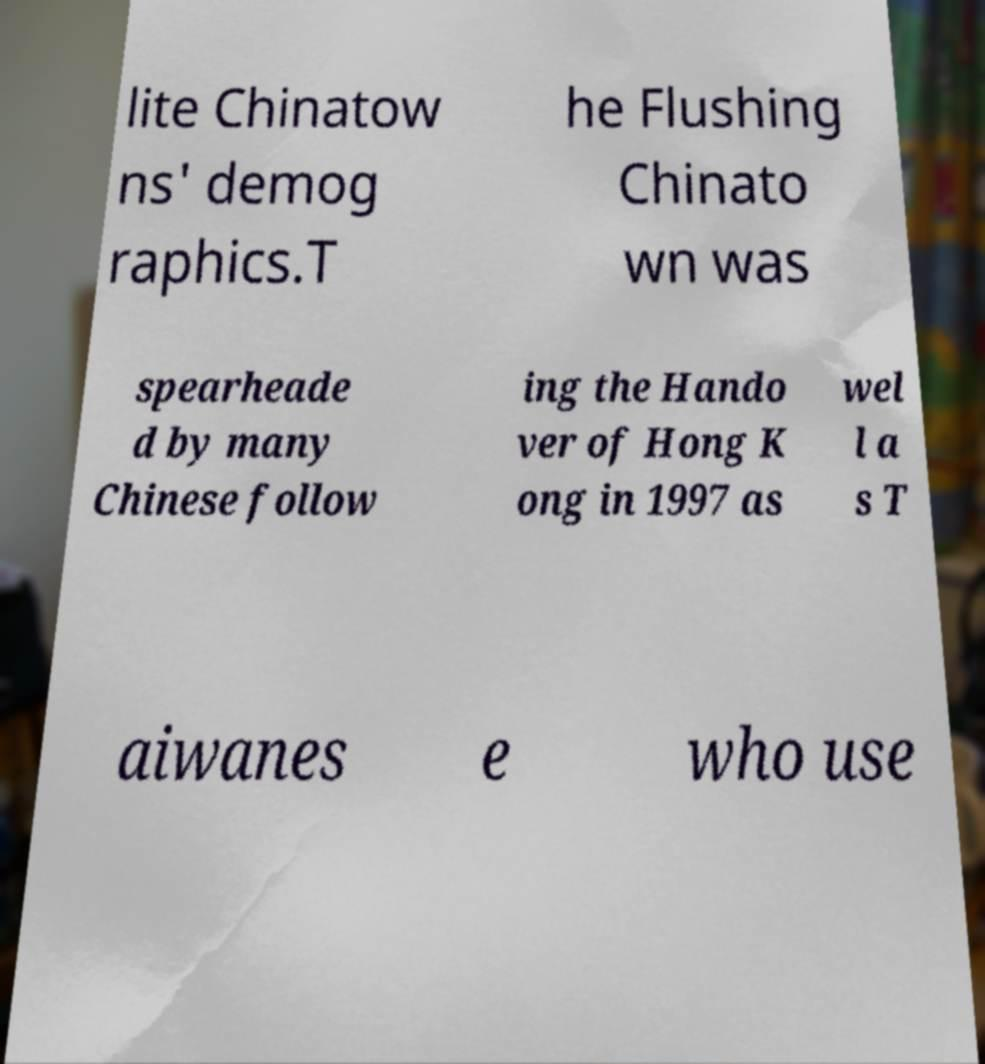Can you accurately transcribe the text from the provided image for me? lite Chinatow ns' demog raphics.T he Flushing Chinato wn was spearheade d by many Chinese follow ing the Hando ver of Hong K ong in 1997 as wel l a s T aiwanes e who use 